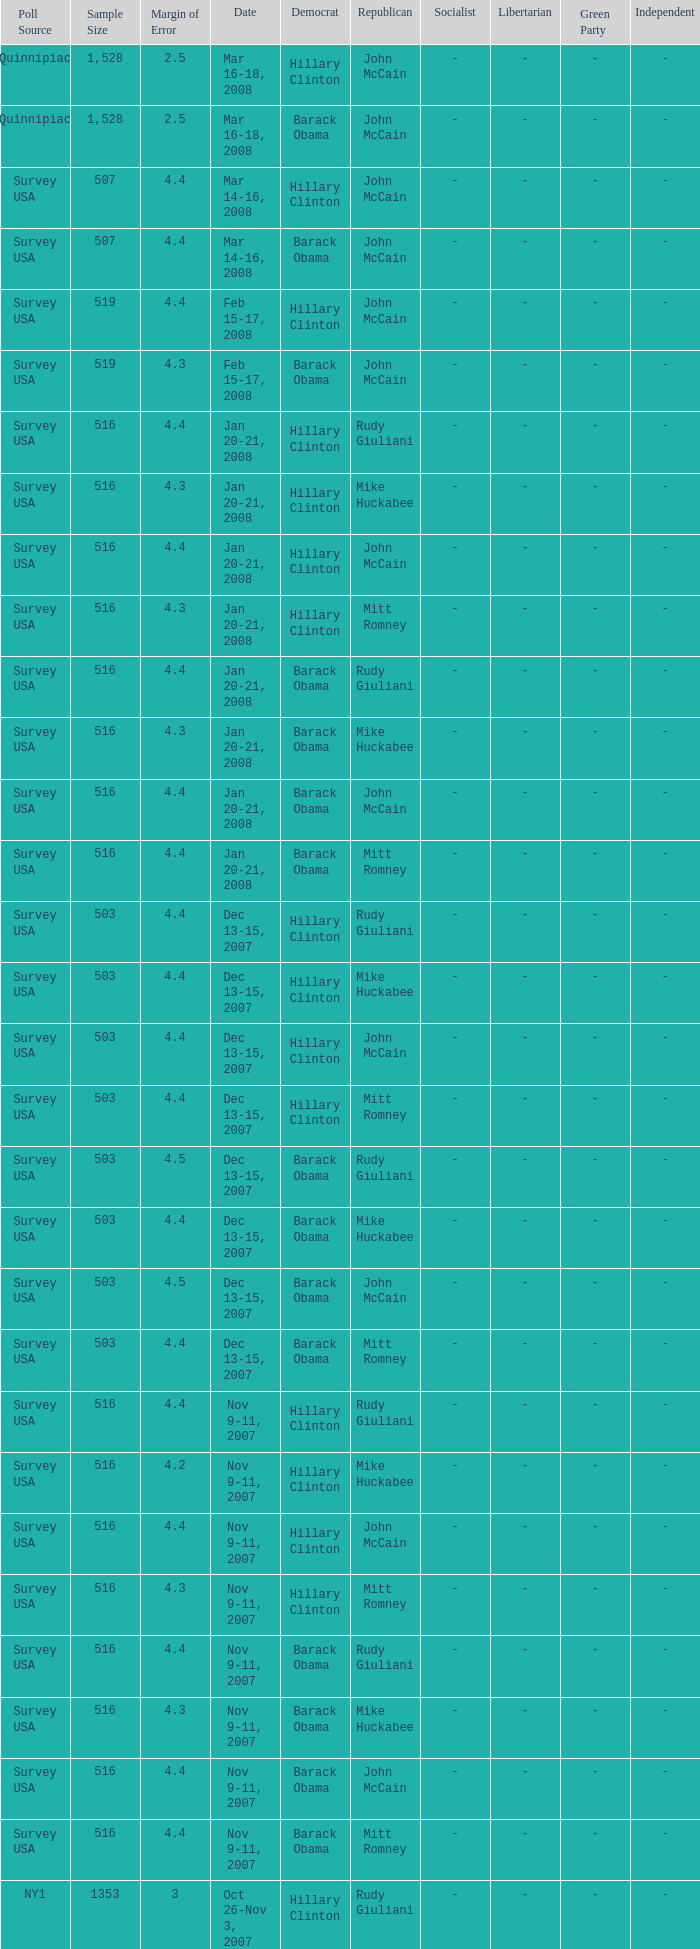What was the date of the poll with a sample size of 496 where Republican Mike Huckabee was chosen? Oct 12-14, 2007. 